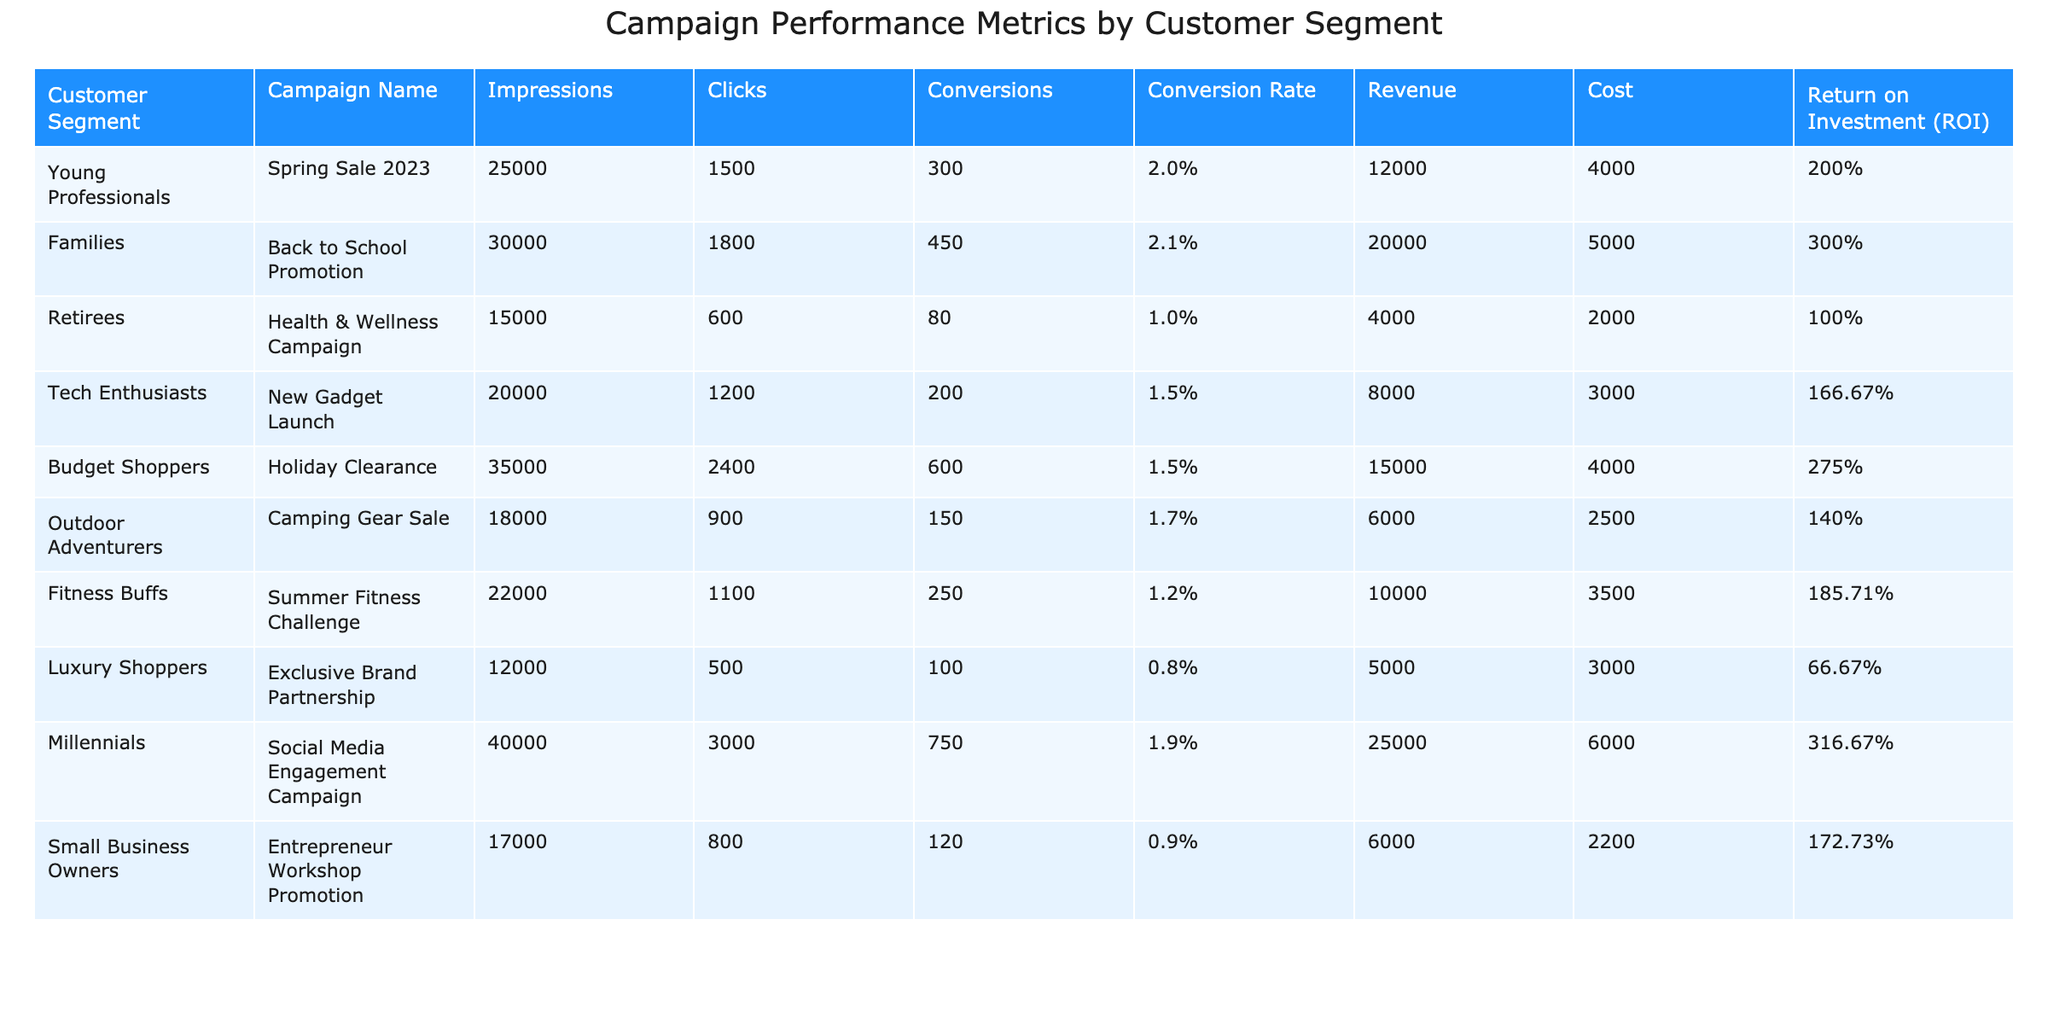What is the ROI for Young Professionals from the Spring Sale 2023 campaign? The ROI for Young Professionals is listed in the table under the Return on Investment (ROI) column for the Spring Sale 2023 campaign, which is 200%.
Answer: 200% Which customer segment had the highest number of conversions? The conversion values can be found in the Conversions column for each customer segment. Families had the highest conversions at 450.
Answer: Families What is the average conversion rate across all customer segments? First, sum all the conversion rates: (2.0% + 2.1% + 1.0% + 1.5% + 1.5% + 1.7% + 1.2% + 0.8% + 1.9% + 0.9%) = 14.6%. Then divide by the number of segments (10), resulting in an average conversion rate of 14.6%/10 = 1.46%.
Answer: 1.46% Which segment spent the least amount on their campaign, and what was the cost? The costs for each campaign are listed in the Cost column. Comparing the values, Luxury Shoppers spent the least at $3,000.
Answer: Luxury Shoppers, $3000 Does the Outdoor Adventurers campaign have a conversion rate above 1.5%? The conversion rate for Outdoor Adventurers is listed in the Conversion Rate column as 1.7%, which is indeed above 1.5%.
Answer: Yes What is the total revenue generated from all campaigns targeting Families and Millennials? The revenue generated from Families is $20,000, and from Millennials is $25,000. Summing these gives $20,000 + $25,000 = $45,000.
Answer: $45,000 Which campaign had the highest revenue, and what was that revenue? By examining the Revenue column, we see that the campaign with the highest revenue was the Millennials campaign, generating $25,000.
Answer: Millennials, $25000 What is the difference in clicks between the campaign for Tech Enthusiasts and Retirees? The clicks for Tech Enthusiasts are 1,200, while for Retirees they are 600. The difference can be calculated as 1,200 - 600 = 600.
Answer: 600 Which customer segments had a conversion rate of 1.2% or lower? Looking through the Conversion Rate column, the segments with 1.2% or lower are Retirees (1.0%), Tech Enthusiasts (1.5% but just above), Luxury Shoppers (0.8%), and Small Business Owners (0.9%). Thus, Retirees, Luxury Shoppers, and Small Business Owners qualify.
Answer: Retirees, Luxury Shoppers, Small Business Owners What is the total number of impressions recorded in the campaigns targeting Budget Shoppers and Fitness Buffs? The impressions for Budget Shoppers are 35,000 and for Fitness Buffs are 22,000. Adding these gives a total of 35,000 + 22,000 = 57,000.
Answer: 57000 